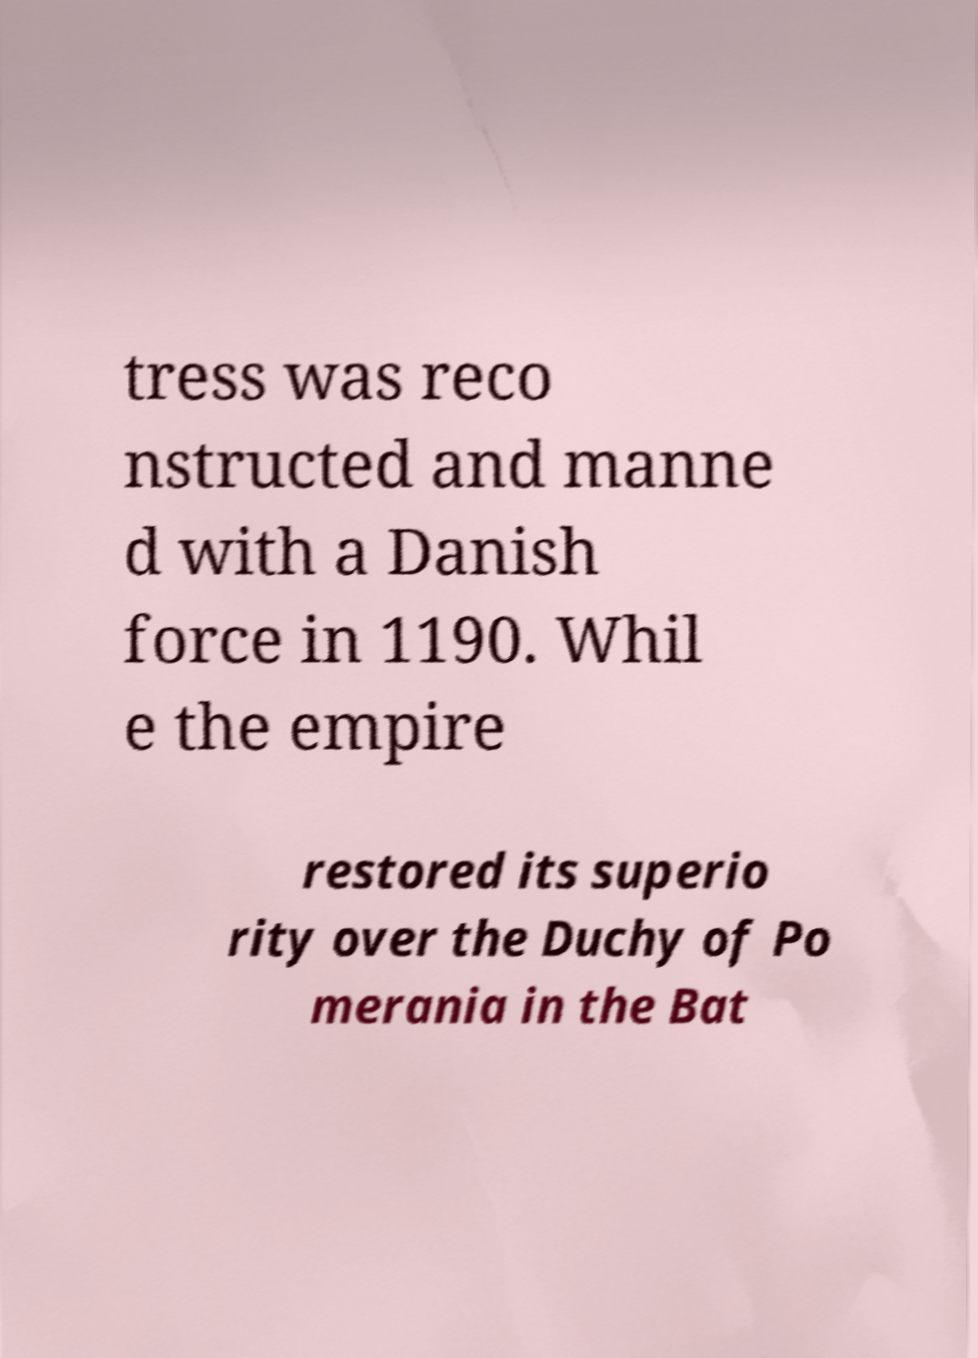I need the written content from this picture converted into text. Can you do that? tress was reco nstructed and manne d with a Danish force in 1190. Whil e the empire restored its superio rity over the Duchy of Po merania in the Bat 